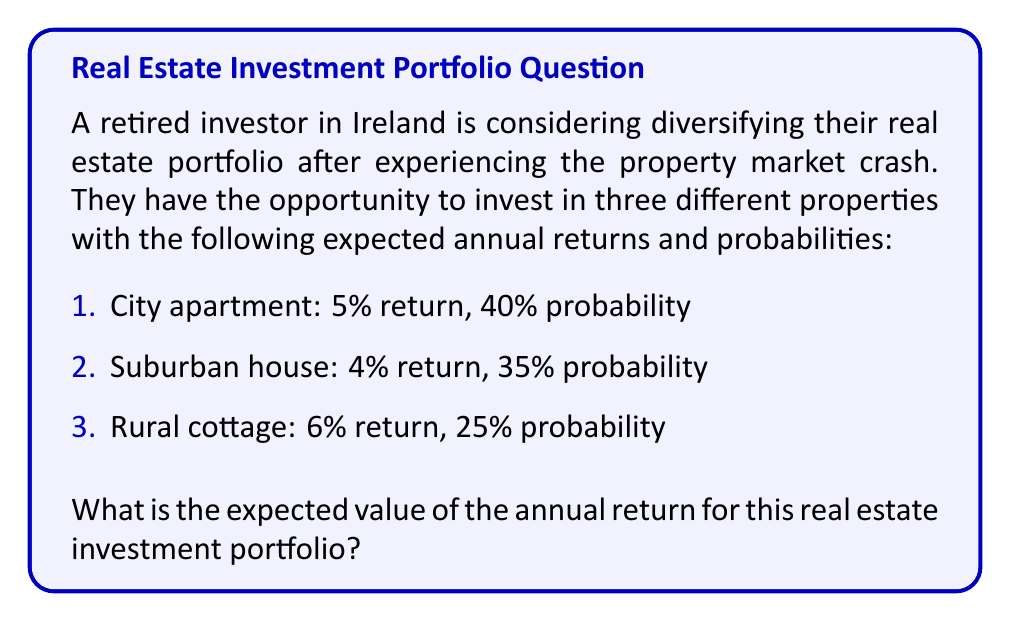Could you help me with this problem? To calculate the expected value of the real estate investment portfolio, we need to follow these steps:

1. Identify the random variable: X = Annual return of the portfolio

2. List the possible outcomes and their probabilities:
   X₁ = 5% (City apartment), P(X₁) = 0.40
   X₂ = 4% (Suburban house), P(X₂) = 0.35
   X₃ = 6% (Rural cottage), P(X₃) = 0.25

3. Apply the expected value formula:
   $$E(X) = \sum_{i=1}^{n} x_i \cdot P(X_i)$$

4. Calculate the expected value:
   $$E(X) = (0.05 \cdot 0.40) + (0.04 \cdot 0.35) + (0.06 \cdot 0.25)$$
   $$E(X) = 0.0200 + 0.0140 + 0.0150$$
   $$E(X) = 0.0490$$

5. Convert the result to a percentage:
   $$E(X) = 0.0490 \cdot 100\% = 4.90\%$$

Therefore, the expected value of the annual return for this real estate investment portfolio is 4.90%.
Answer: 4.90% 